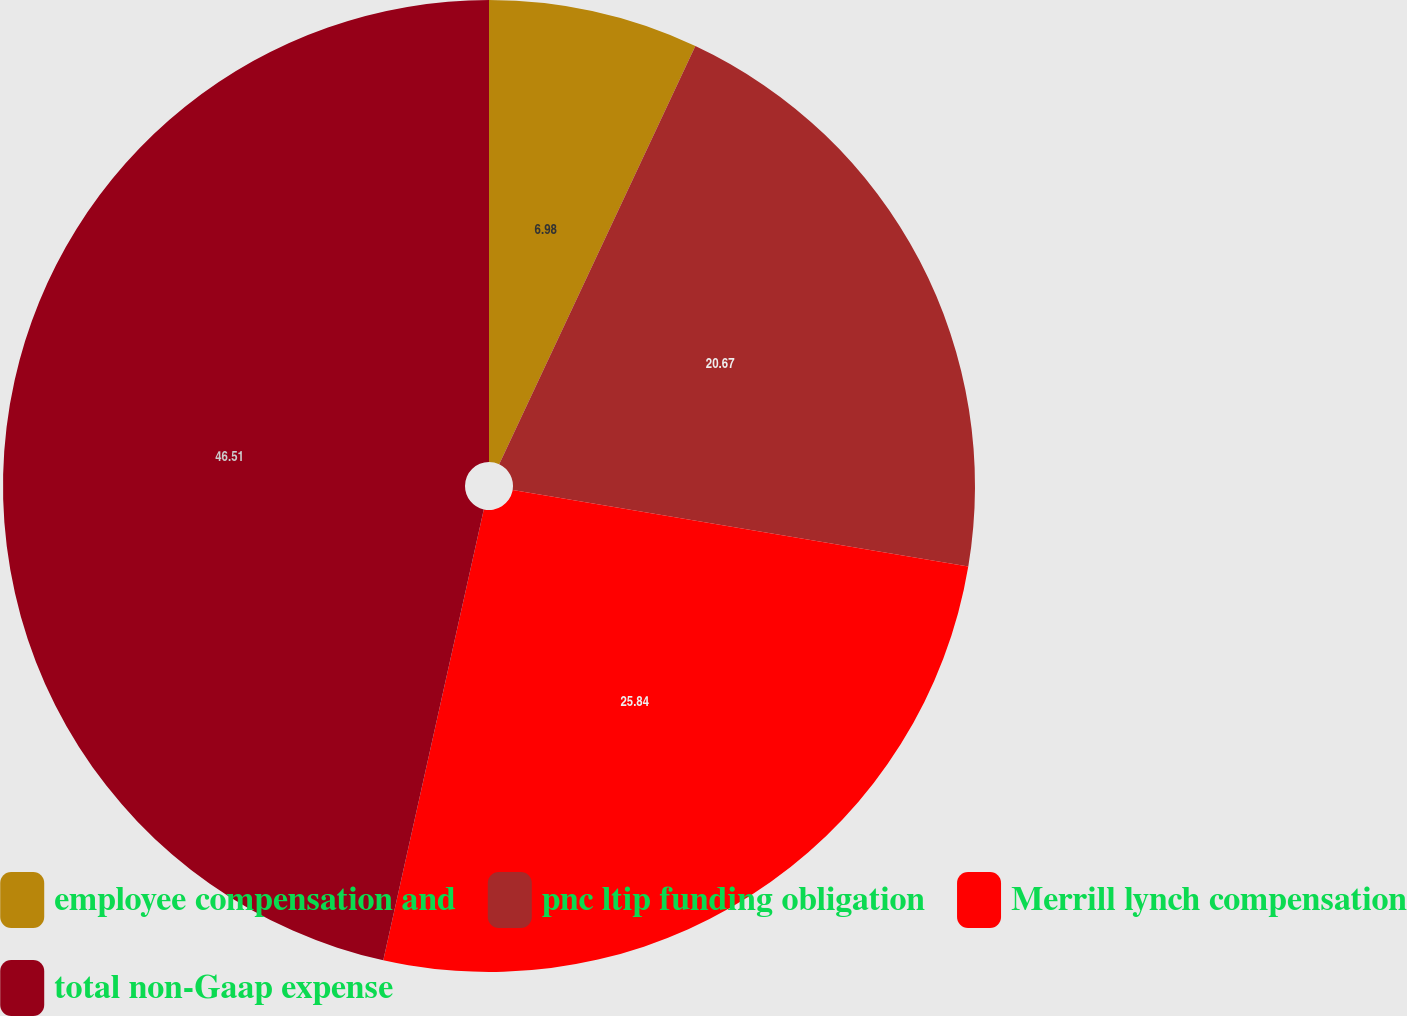<chart> <loc_0><loc_0><loc_500><loc_500><pie_chart><fcel>employee compensation and<fcel>pnc ltip funding obligation<fcel>Merrill lynch compensation<fcel>total non-Gaap expense<nl><fcel>6.98%<fcel>20.67%<fcel>25.84%<fcel>46.51%<nl></chart> 